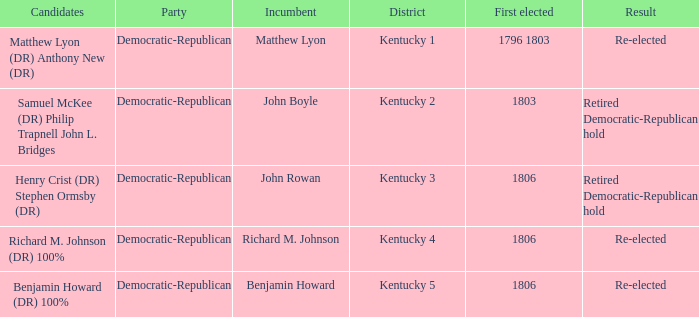Name the first elected for kentucky 3 1806.0. 